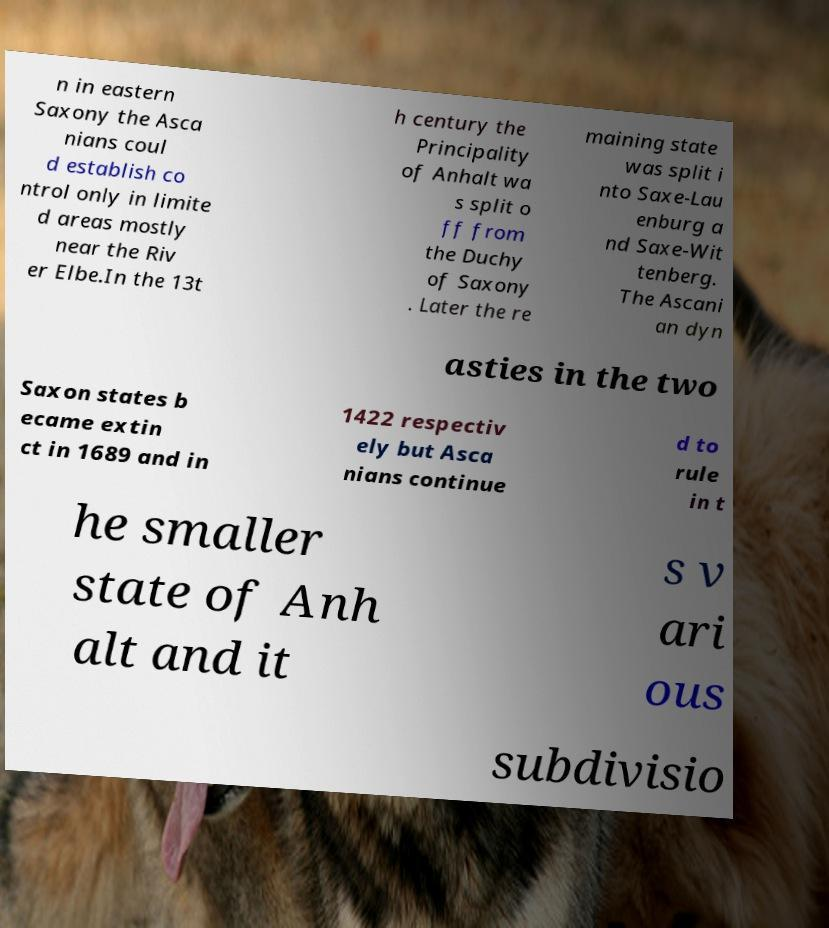Please read and relay the text visible in this image. What does it say? n in eastern Saxony the Asca nians coul d establish co ntrol only in limite d areas mostly near the Riv er Elbe.In the 13t h century the Principality of Anhalt wa s split o ff from the Duchy of Saxony . Later the re maining state was split i nto Saxe-Lau enburg a nd Saxe-Wit tenberg. The Ascani an dyn asties in the two Saxon states b ecame extin ct in 1689 and in 1422 respectiv ely but Asca nians continue d to rule in t he smaller state of Anh alt and it s v ari ous subdivisio 